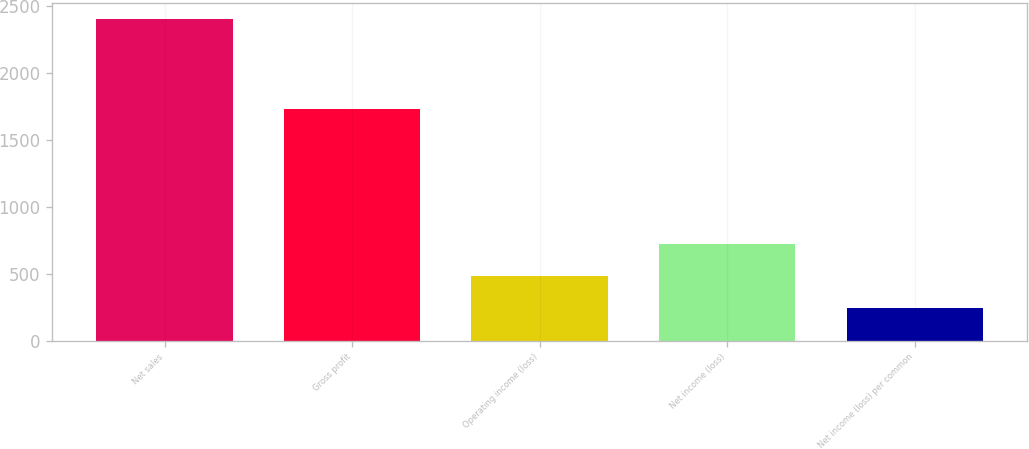<chart> <loc_0><loc_0><loc_500><loc_500><bar_chart><fcel>Net sales<fcel>Gross profit<fcel>Operating income (loss)<fcel>Net income (loss)<fcel>Net income (loss) per common<nl><fcel>2408<fcel>1735<fcel>481.97<fcel>722.73<fcel>241.21<nl></chart> 